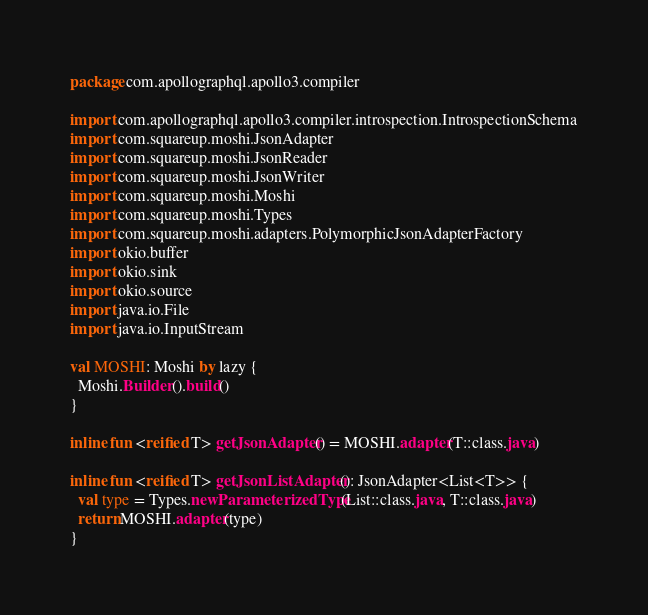Convert code to text. <code><loc_0><loc_0><loc_500><loc_500><_Kotlin_>package com.apollographql.apollo3.compiler

import com.apollographql.apollo3.compiler.introspection.IntrospectionSchema
import com.squareup.moshi.JsonAdapter
import com.squareup.moshi.JsonReader
import com.squareup.moshi.JsonWriter
import com.squareup.moshi.Moshi
import com.squareup.moshi.Types
import com.squareup.moshi.adapters.PolymorphicJsonAdapterFactory
import okio.buffer
import okio.sink
import okio.source
import java.io.File
import java.io.InputStream

val MOSHI: Moshi by lazy {
  Moshi.Builder().build()
}

inline fun <reified T> getJsonAdapter() = MOSHI.adapter(T::class.java)

inline fun <reified T> getJsonListAdapter(): JsonAdapter<List<T>> {
  val type = Types.newParameterizedType(List::class.java, T::class.java)
  return MOSHI.adapter(type)
}
</code> 